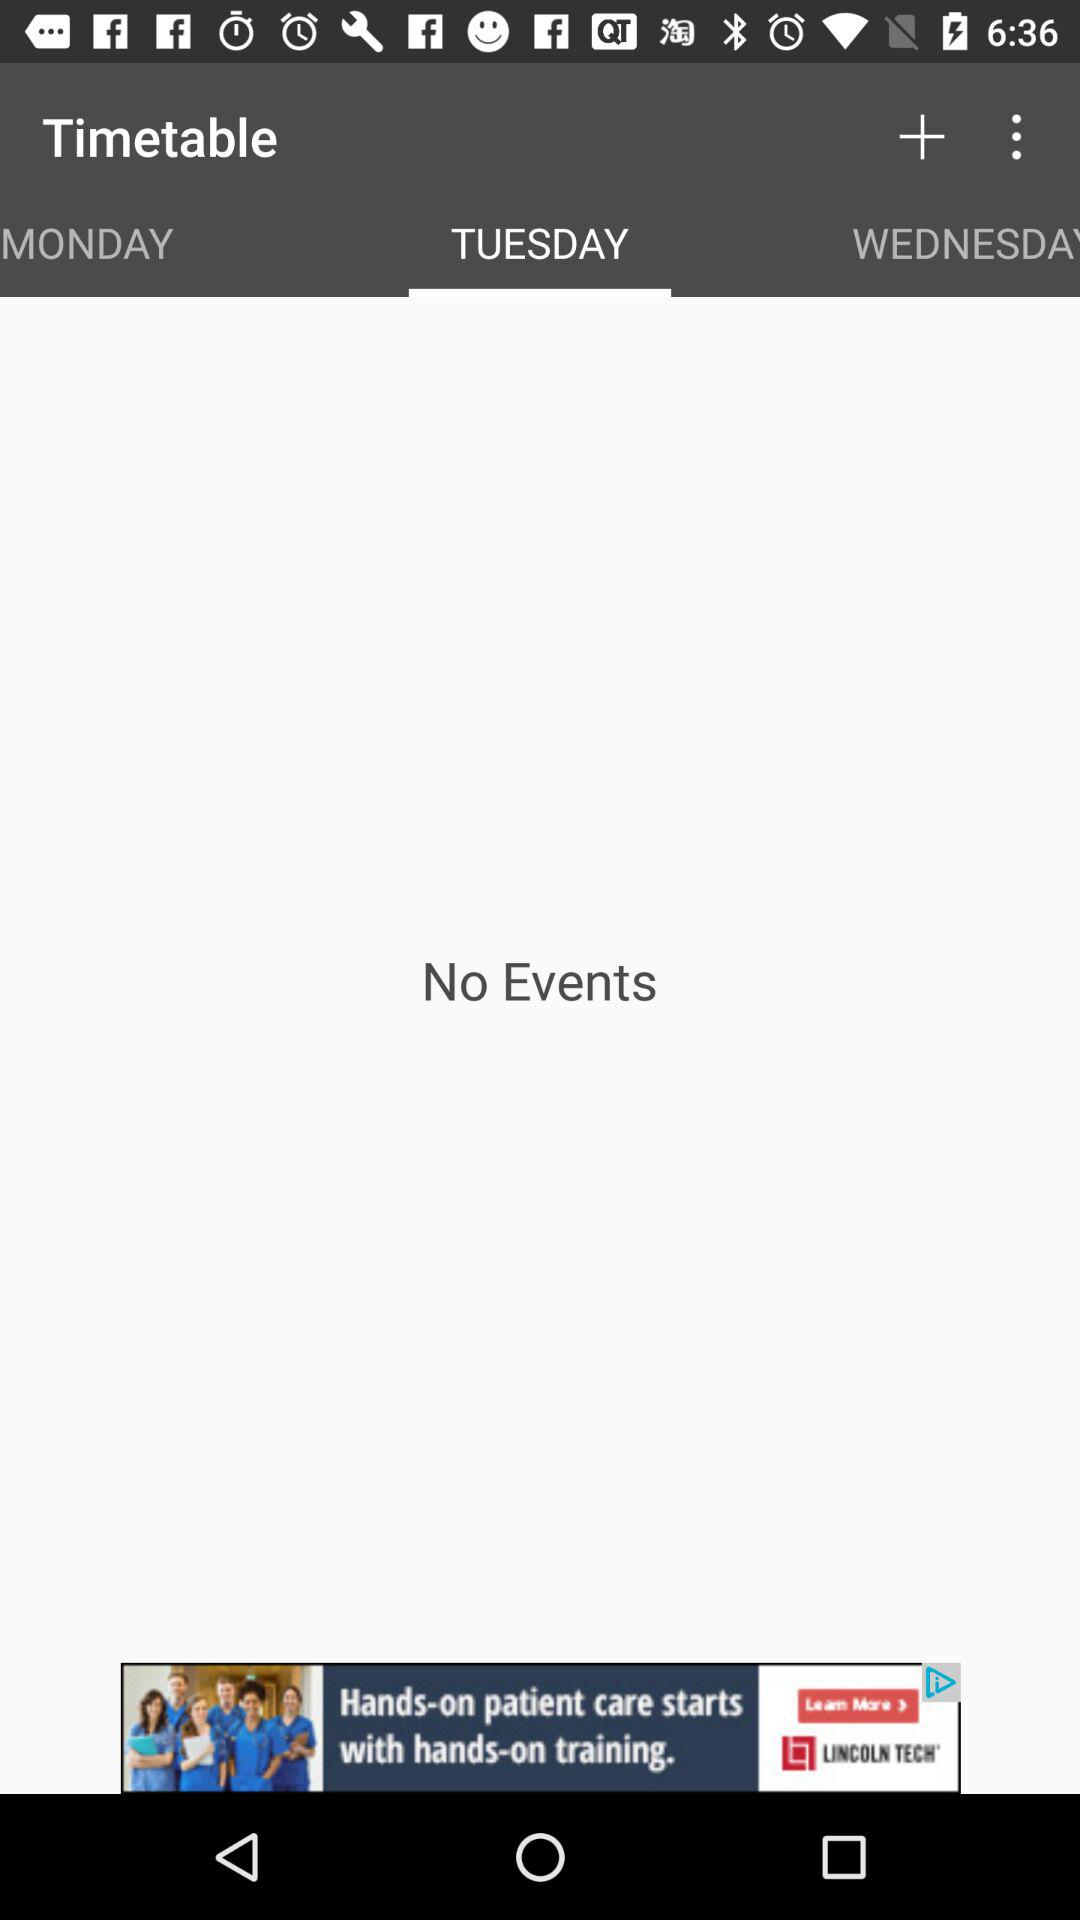Which tab is selected? The selected tab is "TUESDAY". 